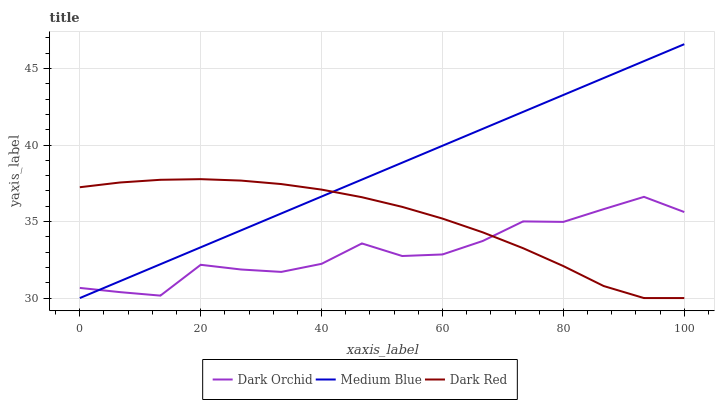Does Dark Orchid have the minimum area under the curve?
Answer yes or no. Yes. Does Medium Blue have the maximum area under the curve?
Answer yes or no. Yes. Does Medium Blue have the minimum area under the curve?
Answer yes or no. No. Does Dark Orchid have the maximum area under the curve?
Answer yes or no. No. Is Medium Blue the smoothest?
Answer yes or no. Yes. Is Dark Orchid the roughest?
Answer yes or no. Yes. Is Dark Orchid the smoothest?
Answer yes or no. No. Is Medium Blue the roughest?
Answer yes or no. No. Does Dark Red have the lowest value?
Answer yes or no. Yes. Does Dark Orchid have the lowest value?
Answer yes or no. No. Does Medium Blue have the highest value?
Answer yes or no. Yes. Does Dark Orchid have the highest value?
Answer yes or no. No. Does Dark Orchid intersect Dark Red?
Answer yes or no. Yes. Is Dark Orchid less than Dark Red?
Answer yes or no. No. Is Dark Orchid greater than Dark Red?
Answer yes or no. No. 